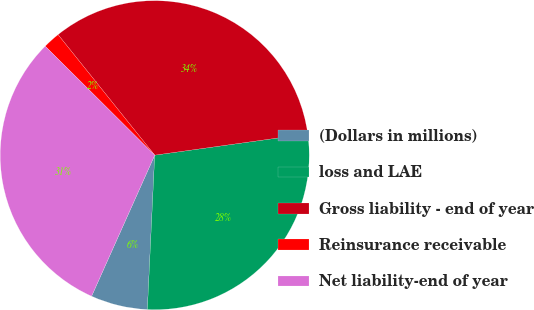<chart> <loc_0><loc_0><loc_500><loc_500><pie_chart><fcel>(Dollars in millions)<fcel>loss and LAE<fcel>Gross liability - end of year<fcel>Reinsurance receivable<fcel>Net liability-end of year<nl><fcel>5.94%<fcel>27.96%<fcel>33.55%<fcel>1.78%<fcel>30.76%<nl></chart> 